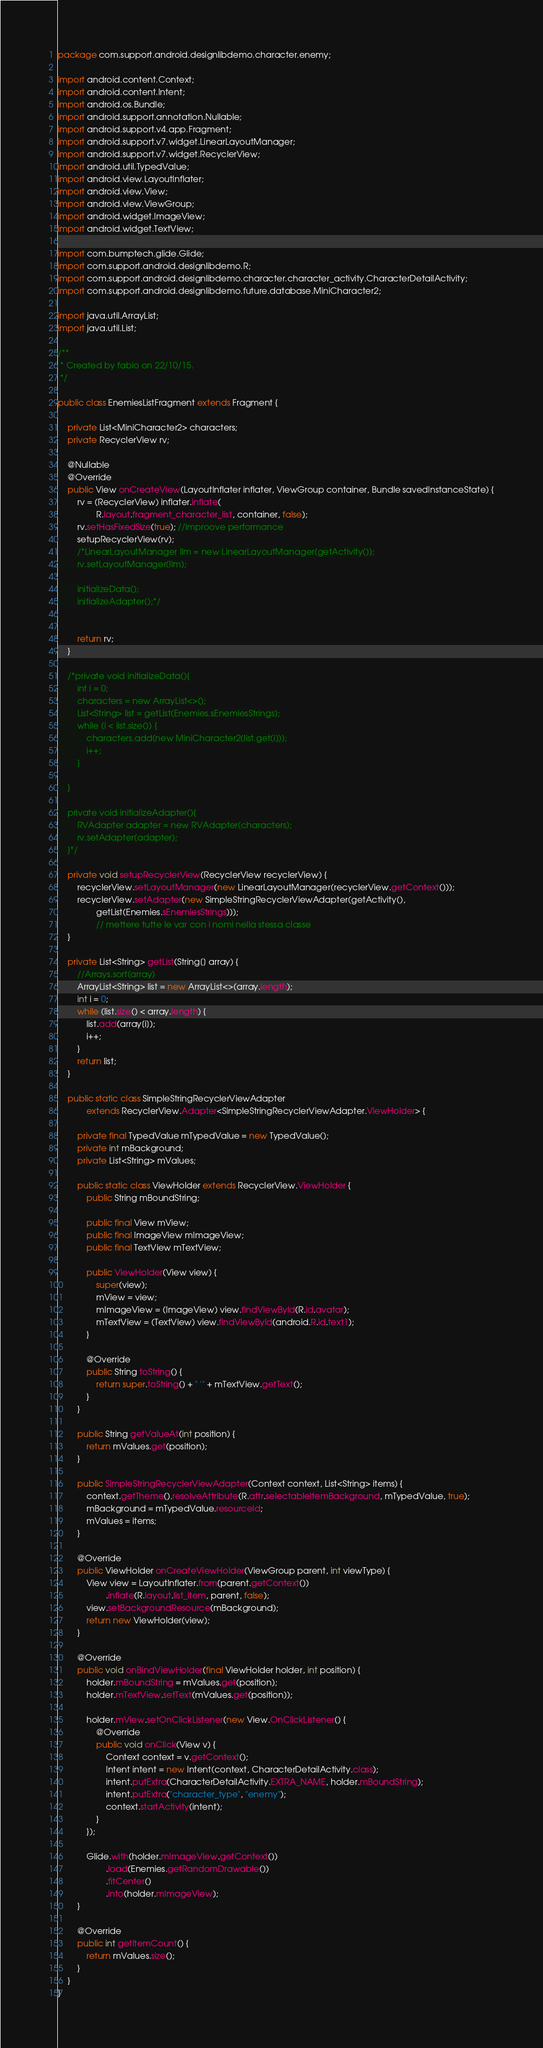Convert code to text. <code><loc_0><loc_0><loc_500><loc_500><_Java_>package com.support.android.designlibdemo.character.enemy;

import android.content.Context;
import android.content.Intent;
import android.os.Bundle;
import android.support.annotation.Nullable;
import android.support.v4.app.Fragment;
import android.support.v7.widget.LinearLayoutManager;
import android.support.v7.widget.RecyclerView;
import android.util.TypedValue;
import android.view.LayoutInflater;
import android.view.View;
import android.view.ViewGroup;
import android.widget.ImageView;
import android.widget.TextView;

import com.bumptech.glide.Glide;
import com.support.android.designlibdemo.R;
import com.support.android.designlibdemo.character.character_activity.CharacterDetailActivity;
import com.support.android.designlibdemo.future.database.MiniCharacter2;

import java.util.ArrayList;
import java.util.List;

/**
 * Created by fabio on 22/10/15.
 */

public class EnemiesListFragment extends Fragment {

    private List<MiniCharacter2> characters;
    private RecyclerView rv;

    @Nullable
    @Override
    public View onCreateView(LayoutInflater inflater, ViewGroup container, Bundle savedInstanceState) {
        rv = (RecyclerView) inflater.inflate(
                R.layout.fragment_character_list, container, false);
        rv.setHasFixedSize(true); //improove performance
        setupRecyclerView(rv);
        /*LinearLayoutManager llm = new LinearLayoutManager(getActivity());
        rv.setLayoutManager(llm);

        initializeData();
        initializeAdapter();*/


        return rv;
    }

    /*private void initializeData(){
        int i = 0;
        characters = new ArrayList<>();
        List<String> list = getList(Enemies.sEnemiesStrings);
        while (i < list.size()) {
            characters.add(new MiniCharacter2(list.get(i)));
            i++;
        }

    }

    private void initializeAdapter(){
        RVAdapter adapter = new RVAdapter(characters);
        rv.setAdapter(adapter);
    }*/

    private void setupRecyclerView(RecyclerView recyclerView) {
        recyclerView.setLayoutManager(new LinearLayoutManager(recyclerView.getContext()));
        recyclerView.setAdapter(new SimpleStringRecyclerViewAdapter(getActivity(),
                getList(Enemies.sEnemiesStrings)));
                // mettere tutte le var con i nomi nella stessa classe
    }

    private List<String> getList(String[] array) {
        //Arrays.sort(array)
        ArrayList<String> list = new ArrayList<>(array.length);
        int i = 0;
        while (list.size() < array.length) {
            list.add(array[i]);
            i++;
        }
        return list;
    }

    public static class SimpleStringRecyclerViewAdapter
            extends RecyclerView.Adapter<SimpleStringRecyclerViewAdapter.ViewHolder> {

        private final TypedValue mTypedValue = new TypedValue();
        private int mBackground;
        private List<String> mValues;

        public static class ViewHolder extends RecyclerView.ViewHolder {
            public String mBoundString;

            public final View mView;
            public final ImageView mImageView;
            public final TextView mTextView;

            public ViewHolder(View view) {
                super(view);
                mView = view;
                mImageView = (ImageView) view.findViewById(R.id.avatar);
                mTextView = (TextView) view.findViewById(android.R.id.text1);
            }

            @Override
            public String toString() {
                return super.toString() + " '" + mTextView.getText();
            }
        }

        public String getValueAt(int position) {
            return mValues.get(position);
        }

        public SimpleStringRecyclerViewAdapter(Context context, List<String> items) {
            context.getTheme().resolveAttribute(R.attr.selectableItemBackground, mTypedValue, true);
            mBackground = mTypedValue.resourceId;
            mValues = items;
        }

        @Override
        public ViewHolder onCreateViewHolder(ViewGroup parent, int viewType) {
            View view = LayoutInflater.from(parent.getContext())
                    .inflate(R.layout.list_item, parent, false);
            view.setBackgroundResource(mBackground);
            return new ViewHolder(view);
        }

        @Override
        public void onBindViewHolder(final ViewHolder holder, int position) {
            holder.mBoundString = mValues.get(position);
            holder.mTextView.setText(mValues.get(position));

            holder.mView.setOnClickListener(new View.OnClickListener() {
                @Override
                public void onClick(View v) {
                    Context context = v.getContext();
                    Intent intent = new Intent(context, CharacterDetailActivity.class);
                    intent.putExtra(CharacterDetailActivity.EXTRA_NAME, holder.mBoundString);
                    intent.putExtra("character_type", "enemy");
                    context.startActivity(intent);
                }
            });

            Glide.with(holder.mImageView.getContext())
                    .load(Enemies.getRandomDrawable())
                    .fitCenter()
                    .into(holder.mImageView);
        }

        @Override
        public int getItemCount() {
            return mValues.size();
        }
    }
}
</code> 